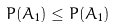<formula> <loc_0><loc_0><loc_500><loc_500>P ( A _ { 1 } ) \leq P ( A _ { 1 } )</formula> 